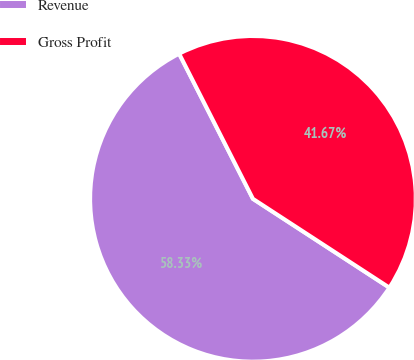<chart> <loc_0><loc_0><loc_500><loc_500><pie_chart><fcel>Revenue<fcel>Gross Profit<nl><fcel>58.33%<fcel>41.67%<nl></chart> 